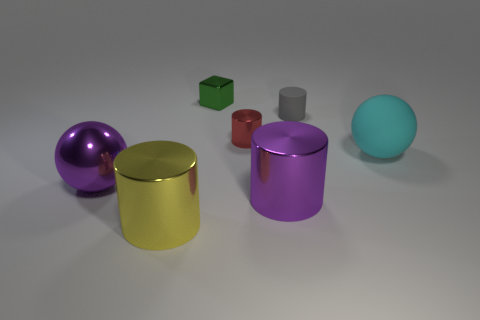The metal thing that is the same color as the big shiny sphere is what size?
Offer a very short reply. Large. The big purple object that is to the right of the purple metallic thing left of the purple metal cylinder is made of what material?
Keep it short and to the point. Metal. Is there a large shiny thing of the same color as the big shiny sphere?
Your answer should be very brief. Yes. What color is the other cylinder that is the same size as the matte cylinder?
Provide a succinct answer. Red. There is a purple object that is in front of the large ball that is to the left of the large metal object right of the big yellow object; what is it made of?
Offer a terse response. Metal. There is a large matte ball; is its color the same as the small shiny cylinder that is behind the yellow thing?
Offer a very short reply. No. What number of objects are either tiny shiny objects right of the green object or big purple metallic objects that are right of the big purple sphere?
Keep it short and to the point. 2. There is a large purple thing that is behind the big purple metal thing to the right of the large shiny sphere; what is its shape?
Ensure brevity in your answer.  Sphere. Is there a small red cylinder that has the same material as the big purple sphere?
Give a very brief answer. Yes. There is another small metal thing that is the same shape as the small gray object; what is its color?
Your response must be concise. Red. 